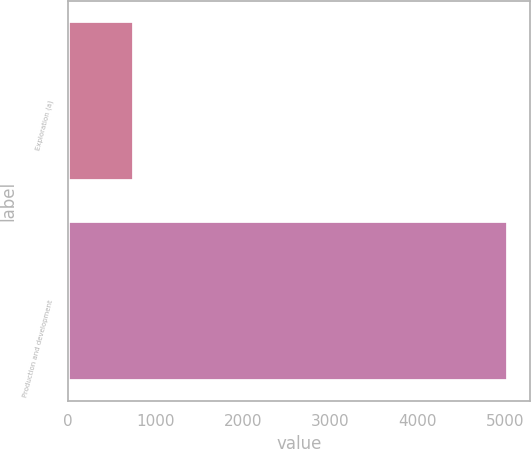Convert chart to OTSL. <chart><loc_0><loc_0><loc_500><loc_500><bar_chart><fcel>Exploration (a)<fcel>Production and development<nl><fcel>763<fcel>5028<nl></chart> 